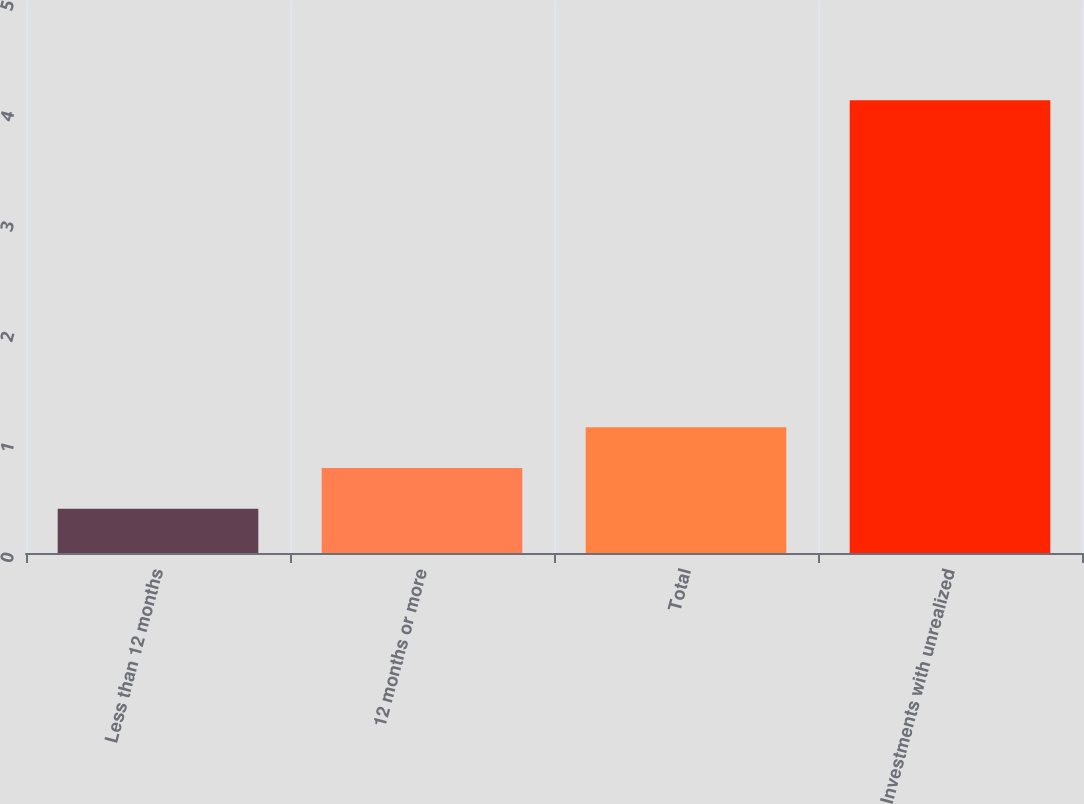Convert chart. <chart><loc_0><loc_0><loc_500><loc_500><bar_chart><fcel>Less than 12 months<fcel>12 months or more<fcel>Total<fcel>Investments with unrealized<nl><fcel>0.4<fcel>0.77<fcel>1.14<fcel>4.1<nl></chart> 